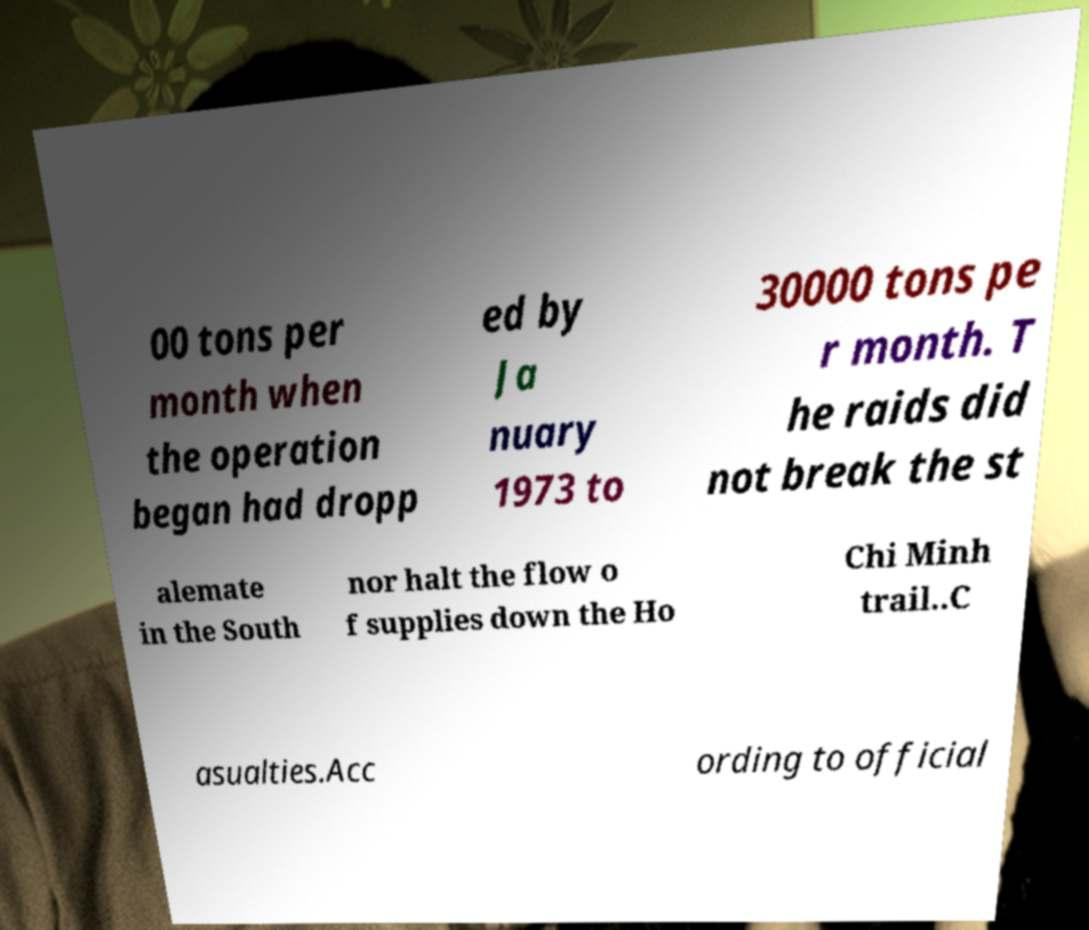Can you accurately transcribe the text from the provided image for me? 00 tons per month when the operation began had dropp ed by Ja nuary 1973 to 30000 tons pe r month. T he raids did not break the st alemate in the South nor halt the flow o f supplies down the Ho Chi Minh trail..C asualties.Acc ording to official 